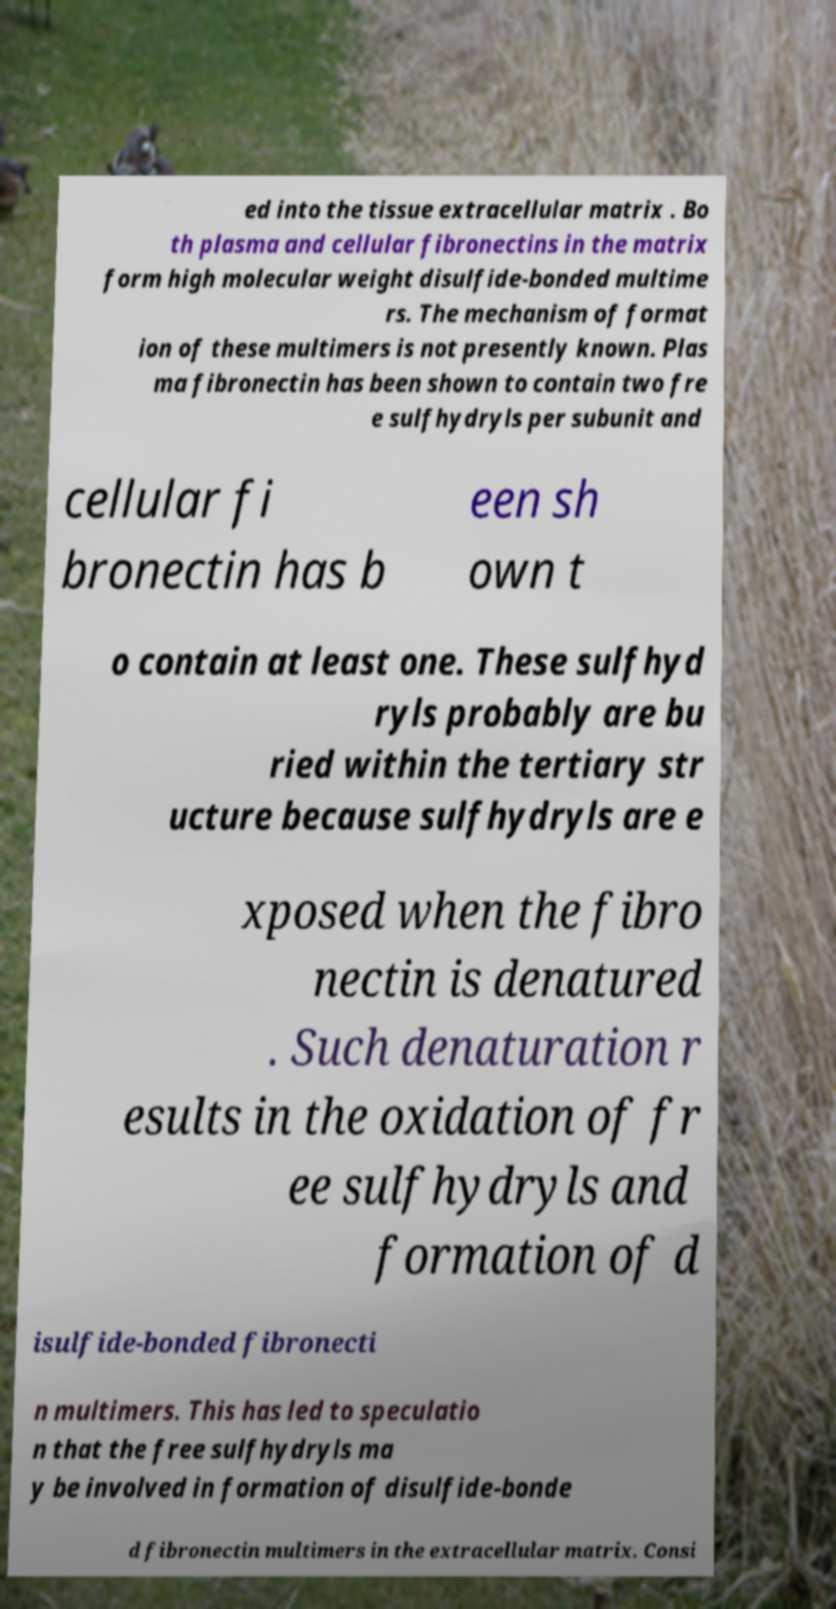Can you read and provide the text displayed in the image?This photo seems to have some interesting text. Can you extract and type it out for me? ed into the tissue extracellular matrix . Bo th plasma and cellular fibronectins in the matrix form high molecular weight disulfide-bonded multime rs. The mechanism of format ion of these multimers is not presently known. Plas ma fibronectin has been shown to contain two fre e sulfhydryls per subunit and cellular fi bronectin has b een sh own t o contain at least one. These sulfhyd ryls probably are bu ried within the tertiary str ucture because sulfhydryls are e xposed when the fibro nectin is denatured . Such denaturation r esults in the oxidation of fr ee sulfhydryls and formation of d isulfide-bonded fibronecti n multimers. This has led to speculatio n that the free sulfhydryls ma y be involved in formation of disulfide-bonde d fibronectin multimers in the extracellular matrix. Consi 